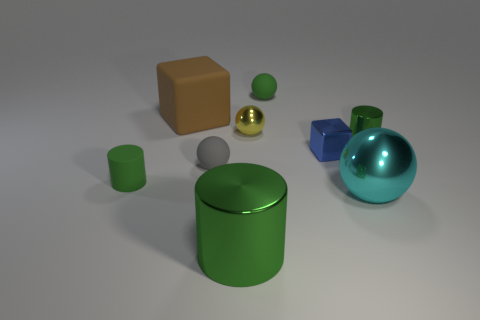Subtract 1 cylinders. How many cylinders are left? 2 Subtract all yellow spheres. How many spheres are left? 3 Subtract all cyan balls. How many balls are left? 3 Add 1 big cyan objects. How many objects exist? 10 Subtract all blue spheres. Subtract all blue cubes. How many spheres are left? 4 Subtract all cylinders. How many objects are left? 6 Add 1 yellow things. How many yellow things are left? 2 Add 5 big brown matte things. How many big brown matte things exist? 6 Subtract 0 cyan blocks. How many objects are left? 9 Subtract all tiny gray rubber balls. Subtract all cyan metal balls. How many objects are left? 7 